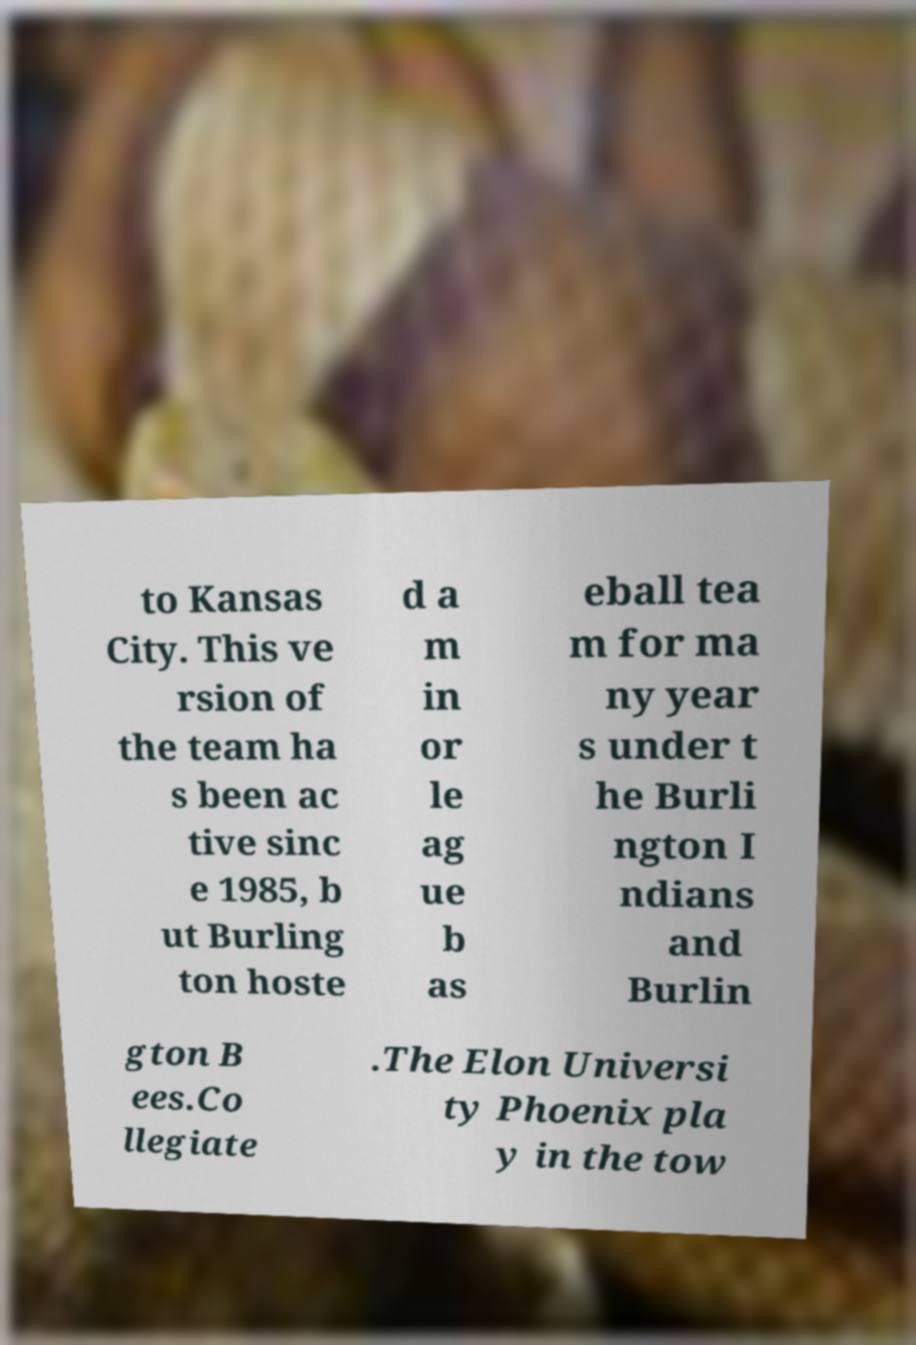Please identify and transcribe the text found in this image. to Kansas City. This ve rsion of the team ha s been ac tive sinc e 1985, b ut Burling ton hoste d a m in or le ag ue b as eball tea m for ma ny year s under t he Burli ngton I ndians and Burlin gton B ees.Co llegiate .The Elon Universi ty Phoenix pla y in the tow 